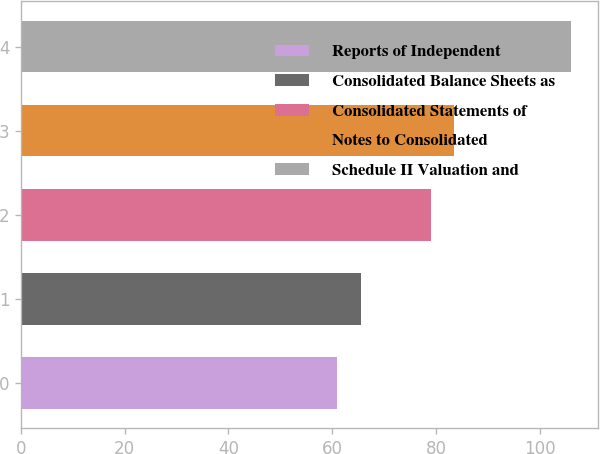Convert chart. <chart><loc_0><loc_0><loc_500><loc_500><bar_chart><fcel>Reports of Independent<fcel>Consolidated Balance Sheets as<fcel>Consolidated Statements of<fcel>Notes to Consolidated<fcel>Schedule II Valuation and<nl><fcel>61<fcel>65.5<fcel>79<fcel>83.5<fcel>106<nl></chart> 